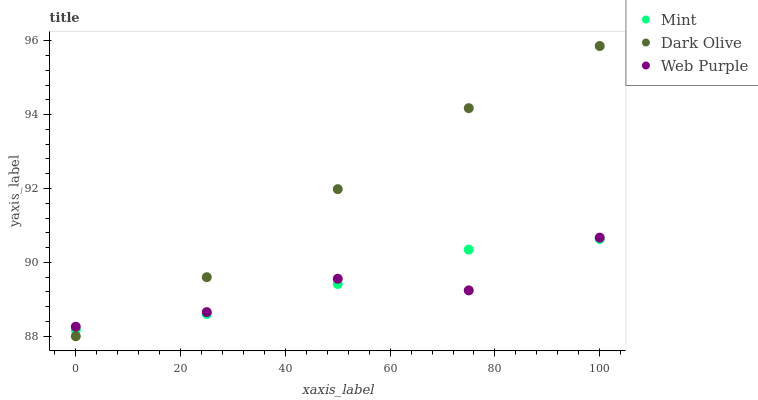Does Web Purple have the minimum area under the curve?
Answer yes or no. Yes. Does Dark Olive have the maximum area under the curve?
Answer yes or no. Yes. Does Mint have the minimum area under the curve?
Answer yes or no. No. Does Mint have the maximum area under the curve?
Answer yes or no. No. Is Mint the smoothest?
Answer yes or no. Yes. Is Web Purple the roughest?
Answer yes or no. Yes. Is Dark Olive the smoothest?
Answer yes or no. No. Is Dark Olive the roughest?
Answer yes or no. No. Does Dark Olive have the lowest value?
Answer yes or no. Yes. Does Mint have the lowest value?
Answer yes or no. No. Does Dark Olive have the highest value?
Answer yes or no. Yes. Does Mint have the highest value?
Answer yes or no. No. Does Dark Olive intersect Mint?
Answer yes or no. Yes. Is Dark Olive less than Mint?
Answer yes or no. No. Is Dark Olive greater than Mint?
Answer yes or no. No. 